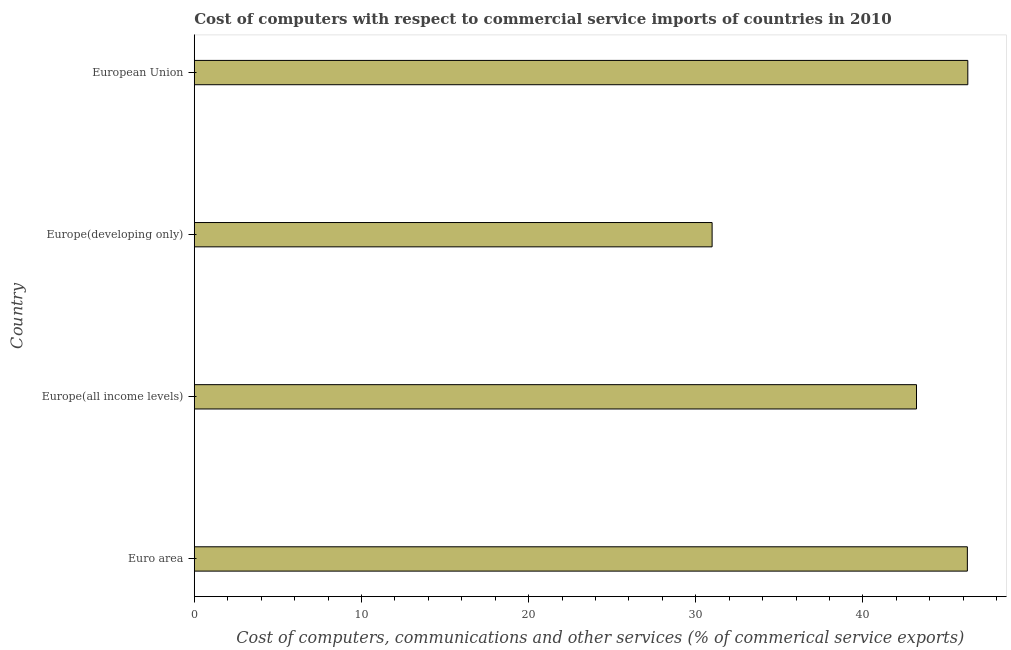Does the graph contain any zero values?
Your answer should be compact. No. What is the title of the graph?
Offer a terse response. Cost of computers with respect to commercial service imports of countries in 2010. What is the label or title of the X-axis?
Keep it short and to the point. Cost of computers, communications and other services (% of commerical service exports). What is the label or title of the Y-axis?
Offer a terse response. Country. What is the  computer and other services in Euro area?
Give a very brief answer. 46.25. Across all countries, what is the maximum cost of communications?
Give a very brief answer. 46.27. Across all countries, what is the minimum  computer and other services?
Your response must be concise. 30.98. In which country was the cost of communications maximum?
Give a very brief answer. European Union. In which country was the cost of communications minimum?
Your response must be concise. Europe(developing only). What is the sum of the  computer and other services?
Provide a short and direct response. 166.7. What is the difference between the  computer and other services in Euro area and Europe(developing only)?
Your response must be concise. 15.27. What is the average  computer and other services per country?
Your answer should be compact. 41.67. What is the median  computer and other services?
Make the answer very short. 44.72. In how many countries, is the  computer and other services greater than 34 %?
Keep it short and to the point. 3. What is the ratio of the cost of communications in Euro area to that in Europe(developing only)?
Your answer should be very brief. 1.49. What is the difference between the highest and the second highest cost of communications?
Your answer should be very brief. 0.03. Is the sum of the  computer and other services in Euro area and Europe(developing only) greater than the maximum  computer and other services across all countries?
Make the answer very short. Yes. In how many countries, is the cost of communications greater than the average cost of communications taken over all countries?
Give a very brief answer. 3. How many countries are there in the graph?
Provide a succinct answer. 4. What is the difference between two consecutive major ticks on the X-axis?
Your response must be concise. 10. What is the Cost of computers, communications and other services (% of commerical service exports) in Euro area?
Make the answer very short. 46.25. What is the Cost of computers, communications and other services (% of commerical service exports) of Europe(all income levels)?
Keep it short and to the point. 43.2. What is the Cost of computers, communications and other services (% of commerical service exports) of Europe(developing only)?
Offer a terse response. 30.98. What is the Cost of computers, communications and other services (% of commerical service exports) of European Union?
Ensure brevity in your answer.  46.27. What is the difference between the Cost of computers, communications and other services (% of commerical service exports) in Euro area and Europe(all income levels)?
Make the answer very short. 3.04. What is the difference between the Cost of computers, communications and other services (% of commerical service exports) in Euro area and Europe(developing only)?
Give a very brief answer. 15.27. What is the difference between the Cost of computers, communications and other services (% of commerical service exports) in Euro area and European Union?
Ensure brevity in your answer.  -0.03. What is the difference between the Cost of computers, communications and other services (% of commerical service exports) in Europe(all income levels) and Europe(developing only)?
Give a very brief answer. 12.23. What is the difference between the Cost of computers, communications and other services (% of commerical service exports) in Europe(all income levels) and European Union?
Give a very brief answer. -3.07. What is the difference between the Cost of computers, communications and other services (% of commerical service exports) in Europe(developing only) and European Union?
Your answer should be compact. -15.3. What is the ratio of the Cost of computers, communications and other services (% of commerical service exports) in Euro area to that in Europe(all income levels)?
Keep it short and to the point. 1.07. What is the ratio of the Cost of computers, communications and other services (% of commerical service exports) in Euro area to that in Europe(developing only)?
Ensure brevity in your answer.  1.49. What is the ratio of the Cost of computers, communications and other services (% of commerical service exports) in Europe(all income levels) to that in Europe(developing only)?
Make the answer very short. 1.4. What is the ratio of the Cost of computers, communications and other services (% of commerical service exports) in Europe(all income levels) to that in European Union?
Offer a very short reply. 0.93. What is the ratio of the Cost of computers, communications and other services (% of commerical service exports) in Europe(developing only) to that in European Union?
Provide a succinct answer. 0.67. 